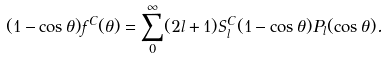Convert formula to latex. <formula><loc_0><loc_0><loc_500><loc_500>( 1 - \cos \theta ) f ^ { C } ( \theta ) = \sum _ { 0 } ^ { \infty } ( 2 l + 1 ) S ^ { C } _ { l } ( 1 - \cos \theta ) P _ { l } ( \cos \theta ) .</formula> 